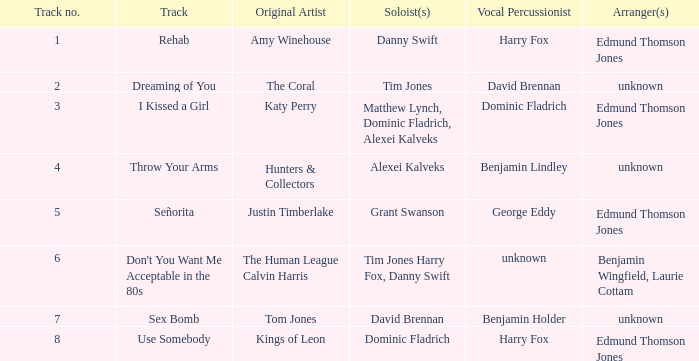Who is the original artist of "Use Somebody"? Kings of Leon. 